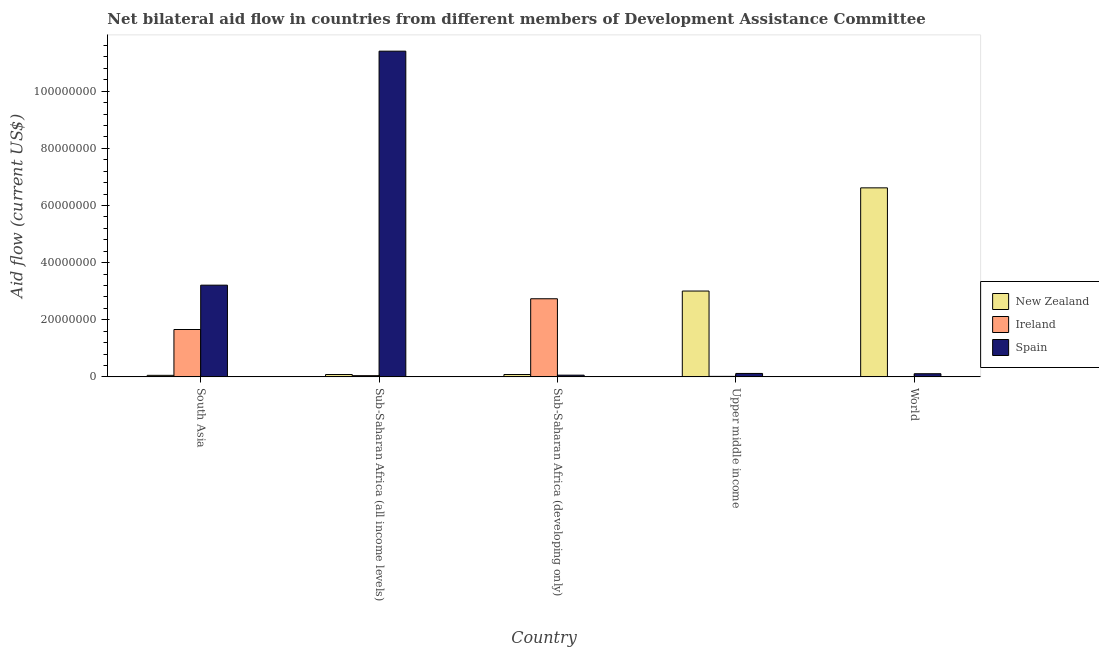How many groups of bars are there?
Your response must be concise. 5. Are the number of bars per tick equal to the number of legend labels?
Your answer should be very brief. Yes. How many bars are there on the 1st tick from the right?
Ensure brevity in your answer.  3. What is the label of the 4th group of bars from the left?
Offer a very short reply. Upper middle income. What is the amount of aid provided by new zealand in World?
Offer a very short reply. 6.62e+07. Across all countries, what is the maximum amount of aid provided by new zealand?
Your answer should be compact. 6.62e+07. Across all countries, what is the minimum amount of aid provided by ireland?
Give a very brief answer. 10000. In which country was the amount of aid provided by spain maximum?
Keep it short and to the point. Sub-Saharan Africa (all income levels). What is the total amount of aid provided by ireland in the graph?
Provide a succinct answer. 4.45e+07. What is the difference between the amount of aid provided by spain in Sub-Saharan Africa (all income levels) and that in World?
Give a very brief answer. 1.13e+08. What is the difference between the amount of aid provided by ireland in Sub-Saharan Africa (all income levels) and the amount of aid provided by new zealand in World?
Provide a succinct answer. -6.57e+07. What is the average amount of aid provided by spain per country?
Ensure brevity in your answer.  2.98e+07. What is the difference between the amount of aid provided by new zealand and amount of aid provided by ireland in World?
Offer a very short reply. 6.62e+07. What is the ratio of the amount of aid provided by spain in South Asia to that in Sub-Saharan Africa (developing only)?
Make the answer very short. 53.5. Is the amount of aid provided by new zealand in Sub-Saharan Africa (all income levels) less than that in World?
Keep it short and to the point. Yes. Is the difference between the amount of aid provided by spain in South Asia and Sub-Saharan Africa (all income levels) greater than the difference between the amount of aid provided by ireland in South Asia and Sub-Saharan Africa (all income levels)?
Make the answer very short. No. What is the difference between the highest and the second highest amount of aid provided by new zealand?
Give a very brief answer. 3.61e+07. What is the difference between the highest and the lowest amount of aid provided by ireland?
Give a very brief answer. 2.73e+07. What does the 2nd bar from the left in Sub-Saharan Africa (all income levels) represents?
Give a very brief answer. Ireland. What does the 2nd bar from the right in World represents?
Provide a short and direct response. Ireland. Is it the case that in every country, the sum of the amount of aid provided by new zealand and amount of aid provided by ireland is greater than the amount of aid provided by spain?
Your answer should be very brief. No. How many bars are there?
Your response must be concise. 15. How many countries are there in the graph?
Offer a terse response. 5. What is the difference between two consecutive major ticks on the Y-axis?
Offer a very short reply. 2.00e+07. What is the title of the graph?
Your response must be concise. Net bilateral aid flow in countries from different members of Development Assistance Committee. What is the label or title of the X-axis?
Provide a short and direct response. Country. What is the label or title of the Y-axis?
Your response must be concise. Aid flow (current US$). What is the Aid flow (current US$) of New Zealand in South Asia?
Your response must be concise. 5.40e+05. What is the Aid flow (current US$) of Ireland in South Asia?
Ensure brevity in your answer.  1.66e+07. What is the Aid flow (current US$) of Spain in South Asia?
Offer a terse response. 3.21e+07. What is the Aid flow (current US$) of New Zealand in Sub-Saharan Africa (all income levels)?
Ensure brevity in your answer.  8.20e+05. What is the Aid flow (current US$) in Ireland in Sub-Saharan Africa (all income levels)?
Your answer should be very brief. 4.20e+05. What is the Aid flow (current US$) in Spain in Sub-Saharan Africa (all income levels)?
Ensure brevity in your answer.  1.14e+08. What is the Aid flow (current US$) in New Zealand in Sub-Saharan Africa (developing only)?
Your response must be concise. 8.20e+05. What is the Aid flow (current US$) in Ireland in Sub-Saharan Africa (developing only)?
Ensure brevity in your answer.  2.73e+07. What is the Aid flow (current US$) of Spain in Sub-Saharan Africa (developing only)?
Your answer should be compact. 6.00e+05. What is the Aid flow (current US$) in New Zealand in Upper middle income?
Give a very brief answer. 3.00e+07. What is the Aid flow (current US$) of Spain in Upper middle income?
Your answer should be compact. 1.20e+06. What is the Aid flow (current US$) in New Zealand in World?
Your answer should be compact. 6.62e+07. What is the Aid flow (current US$) of Ireland in World?
Your answer should be very brief. 10000. What is the Aid flow (current US$) in Spain in World?
Your answer should be compact. 1.10e+06. Across all countries, what is the maximum Aid flow (current US$) of New Zealand?
Provide a succinct answer. 6.62e+07. Across all countries, what is the maximum Aid flow (current US$) of Ireland?
Provide a short and direct response. 2.73e+07. Across all countries, what is the maximum Aid flow (current US$) in Spain?
Provide a succinct answer. 1.14e+08. Across all countries, what is the minimum Aid flow (current US$) in New Zealand?
Offer a very short reply. 5.40e+05. Across all countries, what is the minimum Aid flow (current US$) in Ireland?
Provide a short and direct response. 10000. Across all countries, what is the minimum Aid flow (current US$) in Spain?
Your answer should be very brief. 6.00e+05. What is the total Aid flow (current US$) of New Zealand in the graph?
Your answer should be compact. 9.84e+07. What is the total Aid flow (current US$) in Ireland in the graph?
Your response must be concise. 4.45e+07. What is the total Aid flow (current US$) of Spain in the graph?
Offer a terse response. 1.49e+08. What is the difference between the Aid flow (current US$) in New Zealand in South Asia and that in Sub-Saharan Africa (all income levels)?
Give a very brief answer. -2.80e+05. What is the difference between the Aid flow (current US$) of Ireland in South Asia and that in Sub-Saharan Africa (all income levels)?
Your answer should be compact. 1.62e+07. What is the difference between the Aid flow (current US$) of Spain in South Asia and that in Sub-Saharan Africa (all income levels)?
Ensure brevity in your answer.  -8.19e+07. What is the difference between the Aid flow (current US$) in New Zealand in South Asia and that in Sub-Saharan Africa (developing only)?
Give a very brief answer. -2.80e+05. What is the difference between the Aid flow (current US$) in Ireland in South Asia and that in Sub-Saharan Africa (developing only)?
Keep it short and to the point. -1.08e+07. What is the difference between the Aid flow (current US$) of Spain in South Asia and that in Sub-Saharan Africa (developing only)?
Your response must be concise. 3.15e+07. What is the difference between the Aid flow (current US$) in New Zealand in South Asia and that in Upper middle income?
Offer a terse response. -2.95e+07. What is the difference between the Aid flow (current US$) in Ireland in South Asia and that in Upper middle income?
Give a very brief answer. 1.64e+07. What is the difference between the Aid flow (current US$) of Spain in South Asia and that in Upper middle income?
Offer a very short reply. 3.09e+07. What is the difference between the Aid flow (current US$) in New Zealand in South Asia and that in World?
Keep it short and to the point. -6.56e+07. What is the difference between the Aid flow (current US$) of Ireland in South Asia and that in World?
Your answer should be very brief. 1.66e+07. What is the difference between the Aid flow (current US$) in Spain in South Asia and that in World?
Give a very brief answer. 3.10e+07. What is the difference between the Aid flow (current US$) in Ireland in Sub-Saharan Africa (all income levels) and that in Sub-Saharan Africa (developing only)?
Your answer should be very brief. -2.69e+07. What is the difference between the Aid flow (current US$) of Spain in Sub-Saharan Africa (all income levels) and that in Sub-Saharan Africa (developing only)?
Offer a very short reply. 1.13e+08. What is the difference between the Aid flow (current US$) of New Zealand in Sub-Saharan Africa (all income levels) and that in Upper middle income?
Make the answer very short. -2.92e+07. What is the difference between the Aid flow (current US$) of Ireland in Sub-Saharan Africa (all income levels) and that in Upper middle income?
Provide a succinct answer. 2.50e+05. What is the difference between the Aid flow (current US$) of Spain in Sub-Saharan Africa (all income levels) and that in Upper middle income?
Your answer should be compact. 1.13e+08. What is the difference between the Aid flow (current US$) in New Zealand in Sub-Saharan Africa (all income levels) and that in World?
Ensure brevity in your answer.  -6.53e+07. What is the difference between the Aid flow (current US$) of Spain in Sub-Saharan Africa (all income levels) and that in World?
Give a very brief answer. 1.13e+08. What is the difference between the Aid flow (current US$) of New Zealand in Sub-Saharan Africa (developing only) and that in Upper middle income?
Provide a succinct answer. -2.92e+07. What is the difference between the Aid flow (current US$) in Ireland in Sub-Saharan Africa (developing only) and that in Upper middle income?
Offer a terse response. 2.72e+07. What is the difference between the Aid flow (current US$) in Spain in Sub-Saharan Africa (developing only) and that in Upper middle income?
Provide a short and direct response. -6.00e+05. What is the difference between the Aid flow (current US$) of New Zealand in Sub-Saharan Africa (developing only) and that in World?
Your response must be concise. -6.53e+07. What is the difference between the Aid flow (current US$) of Ireland in Sub-Saharan Africa (developing only) and that in World?
Your answer should be very brief. 2.73e+07. What is the difference between the Aid flow (current US$) of Spain in Sub-Saharan Africa (developing only) and that in World?
Provide a short and direct response. -5.00e+05. What is the difference between the Aid flow (current US$) in New Zealand in Upper middle income and that in World?
Make the answer very short. -3.61e+07. What is the difference between the Aid flow (current US$) in New Zealand in South Asia and the Aid flow (current US$) in Ireland in Sub-Saharan Africa (all income levels)?
Provide a succinct answer. 1.20e+05. What is the difference between the Aid flow (current US$) of New Zealand in South Asia and the Aid flow (current US$) of Spain in Sub-Saharan Africa (all income levels)?
Make the answer very short. -1.13e+08. What is the difference between the Aid flow (current US$) of Ireland in South Asia and the Aid flow (current US$) of Spain in Sub-Saharan Africa (all income levels)?
Provide a succinct answer. -9.74e+07. What is the difference between the Aid flow (current US$) in New Zealand in South Asia and the Aid flow (current US$) in Ireland in Sub-Saharan Africa (developing only)?
Provide a succinct answer. -2.68e+07. What is the difference between the Aid flow (current US$) of Ireland in South Asia and the Aid flow (current US$) of Spain in Sub-Saharan Africa (developing only)?
Provide a short and direct response. 1.60e+07. What is the difference between the Aid flow (current US$) of New Zealand in South Asia and the Aid flow (current US$) of Ireland in Upper middle income?
Offer a very short reply. 3.70e+05. What is the difference between the Aid flow (current US$) in New Zealand in South Asia and the Aid flow (current US$) in Spain in Upper middle income?
Your answer should be compact. -6.60e+05. What is the difference between the Aid flow (current US$) of Ireland in South Asia and the Aid flow (current US$) of Spain in Upper middle income?
Offer a terse response. 1.54e+07. What is the difference between the Aid flow (current US$) in New Zealand in South Asia and the Aid flow (current US$) in Ireland in World?
Your answer should be very brief. 5.30e+05. What is the difference between the Aid flow (current US$) of New Zealand in South Asia and the Aid flow (current US$) of Spain in World?
Your answer should be very brief. -5.60e+05. What is the difference between the Aid flow (current US$) of Ireland in South Asia and the Aid flow (current US$) of Spain in World?
Keep it short and to the point. 1.55e+07. What is the difference between the Aid flow (current US$) of New Zealand in Sub-Saharan Africa (all income levels) and the Aid flow (current US$) of Ireland in Sub-Saharan Africa (developing only)?
Your answer should be compact. -2.65e+07. What is the difference between the Aid flow (current US$) in Ireland in Sub-Saharan Africa (all income levels) and the Aid flow (current US$) in Spain in Sub-Saharan Africa (developing only)?
Make the answer very short. -1.80e+05. What is the difference between the Aid flow (current US$) of New Zealand in Sub-Saharan Africa (all income levels) and the Aid flow (current US$) of Ireland in Upper middle income?
Offer a very short reply. 6.50e+05. What is the difference between the Aid flow (current US$) of New Zealand in Sub-Saharan Africa (all income levels) and the Aid flow (current US$) of Spain in Upper middle income?
Your response must be concise. -3.80e+05. What is the difference between the Aid flow (current US$) in Ireland in Sub-Saharan Africa (all income levels) and the Aid flow (current US$) in Spain in Upper middle income?
Offer a terse response. -7.80e+05. What is the difference between the Aid flow (current US$) of New Zealand in Sub-Saharan Africa (all income levels) and the Aid flow (current US$) of Ireland in World?
Your answer should be compact. 8.10e+05. What is the difference between the Aid flow (current US$) in New Zealand in Sub-Saharan Africa (all income levels) and the Aid flow (current US$) in Spain in World?
Offer a very short reply. -2.80e+05. What is the difference between the Aid flow (current US$) in Ireland in Sub-Saharan Africa (all income levels) and the Aid flow (current US$) in Spain in World?
Your answer should be very brief. -6.80e+05. What is the difference between the Aid flow (current US$) in New Zealand in Sub-Saharan Africa (developing only) and the Aid flow (current US$) in Ireland in Upper middle income?
Offer a very short reply. 6.50e+05. What is the difference between the Aid flow (current US$) of New Zealand in Sub-Saharan Africa (developing only) and the Aid flow (current US$) of Spain in Upper middle income?
Ensure brevity in your answer.  -3.80e+05. What is the difference between the Aid flow (current US$) in Ireland in Sub-Saharan Africa (developing only) and the Aid flow (current US$) in Spain in Upper middle income?
Offer a terse response. 2.61e+07. What is the difference between the Aid flow (current US$) in New Zealand in Sub-Saharan Africa (developing only) and the Aid flow (current US$) in Ireland in World?
Offer a very short reply. 8.10e+05. What is the difference between the Aid flow (current US$) of New Zealand in Sub-Saharan Africa (developing only) and the Aid flow (current US$) of Spain in World?
Ensure brevity in your answer.  -2.80e+05. What is the difference between the Aid flow (current US$) in Ireland in Sub-Saharan Africa (developing only) and the Aid flow (current US$) in Spain in World?
Offer a very short reply. 2.62e+07. What is the difference between the Aid flow (current US$) of New Zealand in Upper middle income and the Aid flow (current US$) of Ireland in World?
Provide a succinct answer. 3.00e+07. What is the difference between the Aid flow (current US$) of New Zealand in Upper middle income and the Aid flow (current US$) of Spain in World?
Your answer should be very brief. 2.89e+07. What is the difference between the Aid flow (current US$) in Ireland in Upper middle income and the Aid flow (current US$) in Spain in World?
Offer a very short reply. -9.30e+05. What is the average Aid flow (current US$) in New Zealand per country?
Your response must be concise. 1.97e+07. What is the average Aid flow (current US$) in Ireland per country?
Give a very brief answer. 8.90e+06. What is the average Aid flow (current US$) of Spain per country?
Give a very brief answer. 2.98e+07. What is the difference between the Aid flow (current US$) in New Zealand and Aid flow (current US$) in Ireland in South Asia?
Offer a terse response. -1.60e+07. What is the difference between the Aid flow (current US$) in New Zealand and Aid flow (current US$) in Spain in South Asia?
Offer a very short reply. -3.16e+07. What is the difference between the Aid flow (current US$) of Ireland and Aid flow (current US$) of Spain in South Asia?
Keep it short and to the point. -1.55e+07. What is the difference between the Aid flow (current US$) in New Zealand and Aid flow (current US$) in Spain in Sub-Saharan Africa (all income levels)?
Ensure brevity in your answer.  -1.13e+08. What is the difference between the Aid flow (current US$) in Ireland and Aid flow (current US$) in Spain in Sub-Saharan Africa (all income levels)?
Ensure brevity in your answer.  -1.14e+08. What is the difference between the Aid flow (current US$) of New Zealand and Aid flow (current US$) of Ireland in Sub-Saharan Africa (developing only)?
Keep it short and to the point. -2.65e+07. What is the difference between the Aid flow (current US$) in New Zealand and Aid flow (current US$) in Spain in Sub-Saharan Africa (developing only)?
Keep it short and to the point. 2.20e+05. What is the difference between the Aid flow (current US$) of Ireland and Aid flow (current US$) of Spain in Sub-Saharan Africa (developing only)?
Provide a succinct answer. 2.67e+07. What is the difference between the Aid flow (current US$) in New Zealand and Aid flow (current US$) in Ireland in Upper middle income?
Your response must be concise. 2.99e+07. What is the difference between the Aid flow (current US$) of New Zealand and Aid flow (current US$) of Spain in Upper middle income?
Ensure brevity in your answer.  2.88e+07. What is the difference between the Aid flow (current US$) in Ireland and Aid flow (current US$) in Spain in Upper middle income?
Your answer should be very brief. -1.03e+06. What is the difference between the Aid flow (current US$) of New Zealand and Aid flow (current US$) of Ireland in World?
Keep it short and to the point. 6.62e+07. What is the difference between the Aid flow (current US$) in New Zealand and Aid flow (current US$) in Spain in World?
Keep it short and to the point. 6.51e+07. What is the difference between the Aid flow (current US$) of Ireland and Aid flow (current US$) of Spain in World?
Your answer should be very brief. -1.09e+06. What is the ratio of the Aid flow (current US$) in New Zealand in South Asia to that in Sub-Saharan Africa (all income levels)?
Provide a succinct answer. 0.66. What is the ratio of the Aid flow (current US$) in Ireland in South Asia to that in Sub-Saharan Africa (all income levels)?
Offer a terse response. 39.48. What is the ratio of the Aid flow (current US$) in Spain in South Asia to that in Sub-Saharan Africa (all income levels)?
Provide a short and direct response. 0.28. What is the ratio of the Aid flow (current US$) of New Zealand in South Asia to that in Sub-Saharan Africa (developing only)?
Offer a very short reply. 0.66. What is the ratio of the Aid flow (current US$) of Ireland in South Asia to that in Sub-Saharan Africa (developing only)?
Ensure brevity in your answer.  0.61. What is the ratio of the Aid flow (current US$) in Spain in South Asia to that in Sub-Saharan Africa (developing only)?
Make the answer very short. 53.5. What is the ratio of the Aid flow (current US$) of New Zealand in South Asia to that in Upper middle income?
Give a very brief answer. 0.02. What is the ratio of the Aid flow (current US$) of Ireland in South Asia to that in Upper middle income?
Provide a succinct answer. 97.53. What is the ratio of the Aid flow (current US$) of Spain in South Asia to that in Upper middle income?
Make the answer very short. 26.75. What is the ratio of the Aid flow (current US$) in New Zealand in South Asia to that in World?
Give a very brief answer. 0.01. What is the ratio of the Aid flow (current US$) in Ireland in South Asia to that in World?
Ensure brevity in your answer.  1658. What is the ratio of the Aid flow (current US$) in Spain in South Asia to that in World?
Your answer should be compact. 29.18. What is the ratio of the Aid flow (current US$) in New Zealand in Sub-Saharan Africa (all income levels) to that in Sub-Saharan Africa (developing only)?
Your answer should be compact. 1. What is the ratio of the Aid flow (current US$) in Ireland in Sub-Saharan Africa (all income levels) to that in Sub-Saharan Africa (developing only)?
Your response must be concise. 0.02. What is the ratio of the Aid flow (current US$) of Spain in Sub-Saharan Africa (all income levels) to that in Sub-Saharan Africa (developing only)?
Give a very brief answer. 190. What is the ratio of the Aid flow (current US$) in New Zealand in Sub-Saharan Africa (all income levels) to that in Upper middle income?
Offer a very short reply. 0.03. What is the ratio of the Aid flow (current US$) in Ireland in Sub-Saharan Africa (all income levels) to that in Upper middle income?
Make the answer very short. 2.47. What is the ratio of the Aid flow (current US$) of Spain in Sub-Saharan Africa (all income levels) to that in Upper middle income?
Offer a very short reply. 95. What is the ratio of the Aid flow (current US$) in New Zealand in Sub-Saharan Africa (all income levels) to that in World?
Make the answer very short. 0.01. What is the ratio of the Aid flow (current US$) of Ireland in Sub-Saharan Africa (all income levels) to that in World?
Ensure brevity in your answer.  42. What is the ratio of the Aid flow (current US$) in Spain in Sub-Saharan Africa (all income levels) to that in World?
Offer a very short reply. 103.64. What is the ratio of the Aid flow (current US$) of New Zealand in Sub-Saharan Africa (developing only) to that in Upper middle income?
Make the answer very short. 0.03. What is the ratio of the Aid flow (current US$) in Ireland in Sub-Saharan Africa (developing only) to that in Upper middle income?
Offer a very short reply. 160.82. What is the ratio of the Aid flow (current US$) in New Zealand in Sub-Saharan Africa (developing only) to that in World?
Provide a succinct answer. 0.01. What is the ratio of the Aid flow (current US$) of Ireland in Sub-Saharan Africa (developing only) to that in World?
Give a very brief answer. 2734. What is the ratio of the Aid flow (current US$) of Spain in Sub-Saharan Africa (developing only) to that in World?
Offer a terse response. 0.55. What is the ratio of the Aid flow (current US$) of New Zealand in Upper middle income to that in World?
Provide a short and direct response. 0.45. What is the ratio of the Aid flow (current US$) in Spain in Upper middle income to that in World?
Keep it short and to the point. 1.09. What is the difference between the highest and the second highest Aid flow (current US$) in New Zealand?
Keep it short and to the point. 3.61e+07. What is the difference between the highest and the second highest Aid flow (current US$) of Ireland?
Your answer should be compact. 1.08e+07. What is the difference between the highest and the second highest Aid flow (current US$) in Spain?
Offer a terse response. 8.19e+07. What is the difference between the highest and the lowest Aid flow (current US$) in New Zealand?
Your answer should be very brief. 6.56e+07. What is the difference between the highest and the lowest Aid flow (current US$) of Ireland?
Offer a very short reply. 2.73e+07. What is the difference between the highest and the lowest Aid flow (current US$) of Spain?
Offer a terse response. 1.13e+08. 